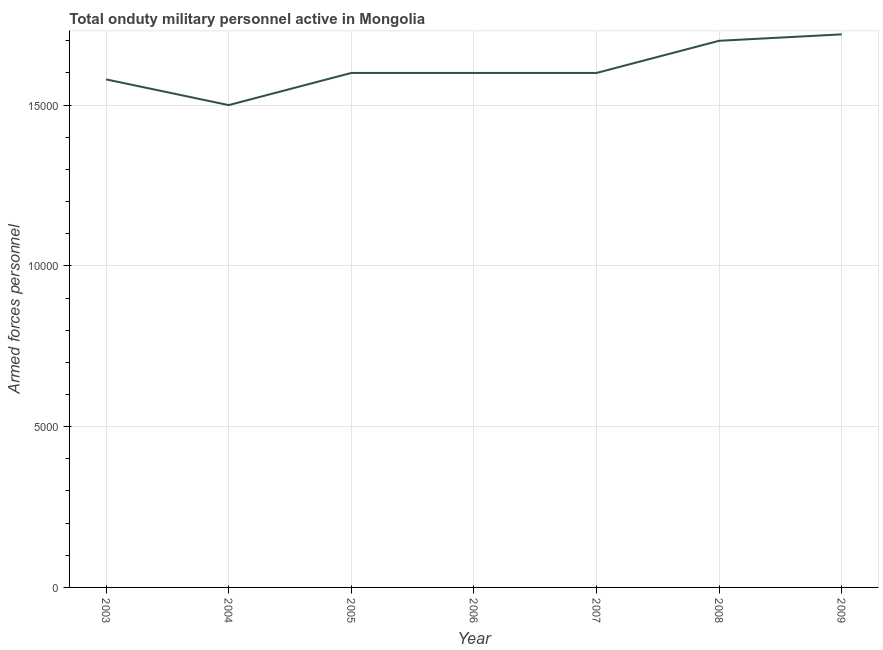What is the number of armed forces personnel in 2008?
Provide a short and direct response. 1.70e+04. Across all years, what is the maximum number of armed forces personnel?
Your answer should be compact. 1.72e+04. Across all years, what is the minimum number of armed forces personnel?
Offer a terse response. 1.50e+04. What is the sum of the number of armed forces personnel?
Your response must be concise. 1.13e+05. What is the average number of armed forces personnel per year?
Provide a succinct answer. 1.61e+04. What is the median number of armed forces personnel?
Give a very brief answer. 1.60e+04. Do a majority of the years between 2005 and 2008 (inclusive) have number of armed forces personnel greater than 16000 ?
Ensure brevity in your answer.  No. What is the ratio of the number of armed forces personnel in 2005 to that in 2008?
Keep it short and to the point. 0.94. Is the difference between the number of armed forces personnel in 2005 and 2007 greater than the difference between any two years?
Provide a succinct answer. No. What is the difference between the highest and the second highest number of armed forces personnel?
Your answer should be compact. 200. Is the sum of the number of armed forces personnel in 2006 and 2009 greater than the maximum number of armed forces personnel across all years?
Give a very brief answer. Yes. What is the difference between the highest and the lowest number of armed forces personnel?
Offer a very short reply. 2200. Does the number of armed forces personnel monotonically increase over the years?
Provide a succinct answer. No. How many years are there in the graph?
Provide a short and direct response. 7. What is the difference between two consecutive major ticks on the Y-axis?
Offer a very short reply. 5000. Are the values on the major ticks of Y-axis written in scientific E-notation?
Make the answer very short. No. Does the graph contain any zero values?
Your answer should be compact. No. What is the title of the graph?
Ensure brevity in your answer.  Total onduty military personnel active in Mongolia. What is the label or title of the Y-axis?
Offer a very short reply. Armed forces personnel. What is the Armed forces personnel in 2003?
Provide a succinct answer. 1.58e+04. What is the Armed forces personnel in 2004?
Ensure brevity in your answer.  1.50e+04. What is the Armed forces personnel of 2005?
Make the answer very short. 1.60e+04. What is the Armed forces personnel of 2006?
Provide a short and direct response. 1.60e+04. What is the Armed forces personnel of 2007?
Offer a terse response. 1.60e+04. What is the Armed forces personnel in 2008?
Offer a very short reply. 1.70e+04. What is the Armed forces personnel in 2009?
Give a very brief answer. 1.72e+04. What is the difference between the Armed forces personnel in 2003 and 2004?
Ensure brevity in your answer.  800. What is the difference between the Armed forces personnel in 2003 and 2005?
Your response must be concise. -200. What is the difference between the Armed forces personnel in 2003 and 2006?
Your answer should be compact. -200. What is the difference between the Armed forces personnel in 2003 and 2007?
Your answer should be compact. -200. What is the difference between the Armed forces personnel in 2003 and 2008?
Offer a very short reply. -1200. What is the difference between the Armed forces personnel in 2003 and 2009?
Keep it short and to the point. -1400. What is the difference between the Armed forces personnel in 2004 and 2005?
Your response must be concise. -1000. What is the difference between the Armed forces personnel in 2004 and 2006?
Make the answer very short. -1000. What is the difference between the Armed forces personnel in 2004 and 2007?
Keep it short and to the point. -1000. What is the difference between the Armed forces personnel in 2004 and 2008?
Keep it short and to the point. -2000. What is the difference between the Armed forces personnel in 2004 and 2009?
Provide a short and direct response. -2200. What is the difference between the Armed forces personnel in 2005 and 2008?
Offer a very short reply. -1000. What is the difference between the Armed forces personnel in 2005 and 2009?
Make the answer very short. -1200. What is the difference between the Armed forces personnel in 2006 and 2007?
Your answer should be compact. 0. What is the difference between the Armed forces personnel in 2006 and 2008?
Your answer should be very brief. -1000. What is the difference between the Armed forces personnel in 2006 and 2009?
Provide a succinct answer. -1200. What is the difference between the Armed forces personnel in 2007 and 2008?
Offer a very short reply. -1000. What is the difference between the Armed forces personnel in 2007 and 2009?
Keep it short and to the point. -1200. What is the difference between the Armed forces personnel in 2008 and 2009?
Make the answer very short. -200. What is the ratio of the Armed forces personnel in 2003 to that in 2004?
Provide a succinct answer. 1.05. What is the ratio of the Armed forces personnel in 2003 to that in 2006?
Provide a short and direct response. 0.99. What is the ratio of the Armed forces personnel in 2003 to that in 2007?
Your answer should be very brief. 0.99. What is the ratio of the Armed forces personnel in 2003 to that in 2008?
Your answer should be compact. 0.93. What is the ratio of the Armed forces personnel in 2003 to that in 2009?
Give a very brief answer. 0.92. What is the ratio of the Armed forces personnel in 2004 to that in 2005?
Your answer should be compact. 0.94. What is the ratio of the Armed forces personnel in 2004 to that in 2006?
Your answer should be compact. 0.94. What is the ratio of the Armed forces personnel in 2004 to that in 2007?
Give a very brief answer. 0.94. What is the ratio of the Armed forces personnel in 2004 to that in 2008?
Offer a terse response. 0.88. What is the ratio of the Armed forces personnel in 2004 to that in 2009?
Provide a short and direct response. 0.87. What is the ratio of the Armed forces personnel in 2005 to that in 2007?
Offer a very short reply. 1. What is the ratio of the Armed forces personnel in 2005 to that in 2008?
Offer a very short reply. 0.94. What is the ratio of the Armed forces personnel in 2006 to that in 2008?
Keep it short and to the point. 0.94. What is the ratio of the Armed forces personnel in 2007 to that in 2008?
Ensure brevity in your answer.  0.94. What is the ratio of the Armed forces personnel in 2008 to that in 2009?
Offer a terse response. 0.99. 